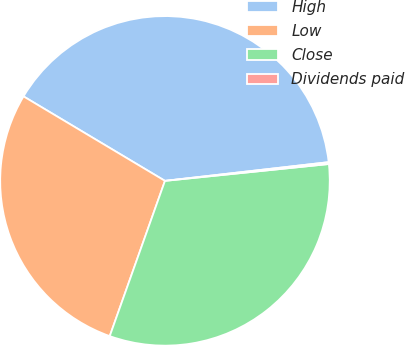<chart> <loc_0><loc_0><loc_500><loc_500><pie_chart><fcel>High<fcel>Low<fcel>Close<fcel>Dividends paid<nl><fcel>39.62%<fcel>28.13%<fcel>32.07%<fcel>0.18%<nl></chart> 